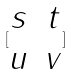Convert formula to latex. <formula><loc_0><loc_0><loc_500><loc_500>[ \begin{matrix} s & t \\ u & v \end{matrix} ]</formula> 